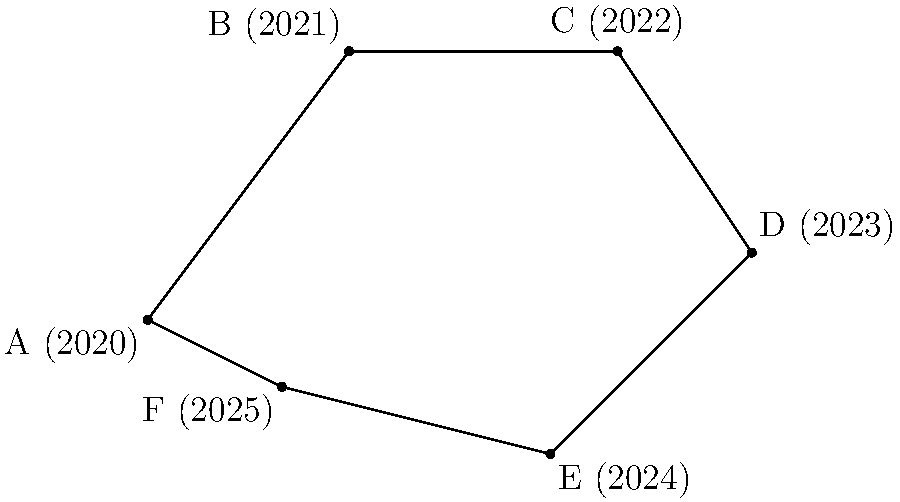The irregular polygon ABCDEF represents Finland's projected economic growth from 2020 to 2025, where each point corresponds to a year and its position reflects the economic status. If each unit in the coordinate system represents €10 billion in GDP, calculate the perimeter of the polygon. Round your answer to the nearest billion euros. To find the perimeter, we need to calculate the length of each side and sum them up:

1) AB: $\sqrt{(3-0)^2 + (4-0)^2} = 5$
2) BC: $\sqrt{(7-3)^2 + (4-4)^2} = 4$
3) CD: $\sqrt{(9-7)^2 + (1-4)^2} = \sqrt{13}$
4) DE: $\sqrt{(6-9)^2 + (-2-1)^2} = 5$
5) EF: $\sqrt{(2-6)^2 + (-1+2)^2} = \sqrt{17}$
6) FA: $\sqrt{(0-2)^2 + (0+1)^2} = \sqrt{5}$

Sum: $5 + 4 + \sqrt{13} + 5 + \sqrt{17} + \sqrt{5} \approx 18.97$

Multiply by 10 (as each unit represents €10 billion): $18.97 * 10 = 189.7$

Rounding to the nearest billion: 190
Answer: €190 billion 